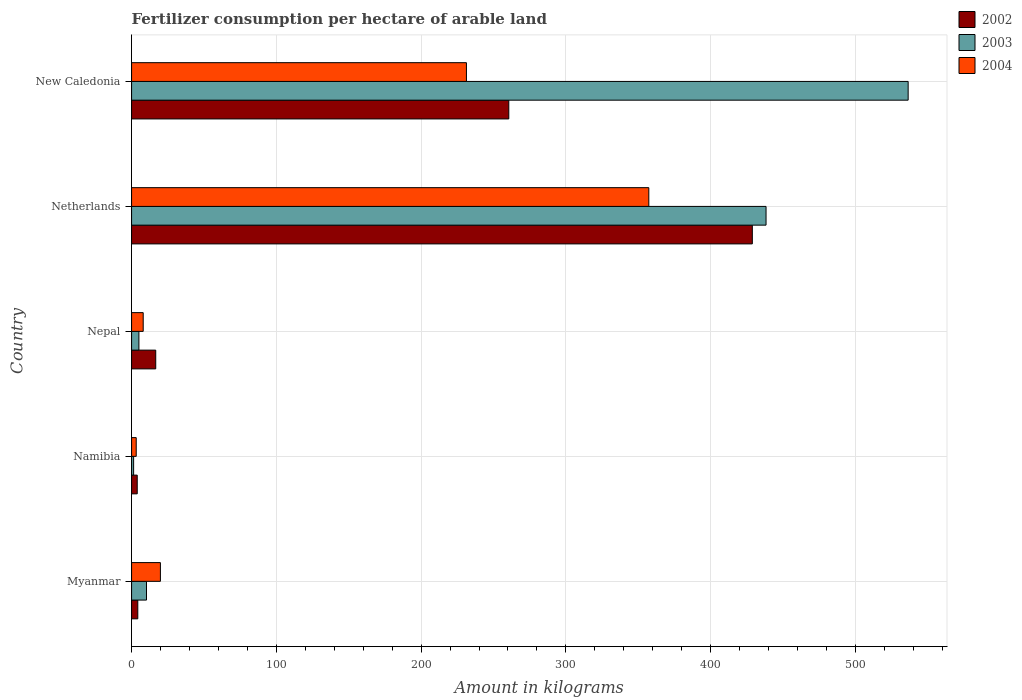How many different coloured bars are there?
Make the answer very short. 3. How many groups of bars are there?
Offer a very short reply. 5. What is the amount of fertilizer consumption in 2003 in Nepal?
Keep it short and to the point. 5.06. Across all countries, what is the maximum amount of fertilizer consumption in 2002?
Your answer should be very brief. 428.82. Across all countries, what is the minimum amount of fertilizer consumption in 2002?
Your answer should be compact. 3.9. In which country was the amount of fertilizer consumption in 2002 maximum?
Keep it short and to the point. Netherlands. In which country was the amount of fertilizer consumption in 2002 minimum?
Offer a very short reply. Namibia. What is the total amount of fertilizer consumption in 2002 in the graph?
Keep it short and to the point. 714.29. What is the difference between the amount of fertilizer consumption in 2003 in Myanmar and that in Netherlands?
Provide a succinct answer. -427.98. What is the difference between the amount of fertilizer consumption in 2004 in Nepal and the amount of fertilizer consumption in 2002 in New Caledonia?
Ensure brevity in your answer.  -252.56. What is the average amount of fertilizer consumption in 2003 per country?
Keep it short and to the point. 198.31. What is the difference between the amount of fertilizer consumption in 2003 and amount of fertilizer consumption in 2004 in New Caledonia?
Ensure brevity in your answer.  305.15. In how many countries, is the amount of fertilizer consumption in 2002 greater than 480 kg?
Offer a terse response. 0. What is the ratio of the amount of fertilizer consumption in 2004 in Myanmar to that in Nepal?
Your response must be concise. 2.48. Is the amount of fertilizer consumption in 2002 in Myanmar less than that in Nepal?
Offer a very short reply. Yes. What is the difference between the highest and the second highest amount of fertilizer consumption in 2003?
Offer a terse response. 98.18. What is the difference between the highest and the lowest amount of fertilizer consumption in 2004?
Provide a succinct answer. 354.11. In how many countries, is the amount of fertilizer consumption in 2002 greater than the average amount of fertilizer consumption in 2002 taken over all countries?
Make the answer very short. 2. Is the sum of the amount of fertilizer consumption in 2002 in Netherlands and New Caledonia greater than the maximum amount of fertilizer consumption in 2003 across all countries?
Give a very brief answer. Yes. What does the 2nd bar from the top in Netherlands represents?
Provide a short and direct response. 2003. What does the 3rd bar from the bottom in Nepal represents?
Your response must be concise. 2004. Is it the case that in every country, the sum of the amount of fertilizer consumption in 2002 and amount of fertilizer consumption in 2003 is greater than the amount of fertilizer consumption in 2004?
Keep it short and to the point. No. What is the difference between two consecutive major ticks on the X-axis?
Offer a terse response. 100. Are the values on the major ticks of X-axis written in scientific E-notation?
Provide a short and direct response. No. Does the graph contain any zero values?
Offer a very short reply. No. Where does the legend appear in the graph?
Provide a short and direct response. Top right. How are the legend labels stacked?
Make the answer very short. Vertical. What is the title of the graph?
Offer a terse response. Fertilizer consumption per hectare of arable land. What is the label or title of the X-axis?
Offer a very short reply. Amount in kilograms. What is the label or title of the Y-axis?
Keep it short and to the point. Country. What is the Amount in kilograms in 2002 in Myanmar?
Offer a terse response. 4.29. What is the Amount in kilograms in 2003 in Myanmar?
Ensure brevity in your answer.  10.31. What is the Amount in kilograms of 2004 in Myanmar?
Your answer should be compact. 19.91. What is the Amount in kilograms of 2002 in Namibia?
Make the answer very short. 3.9. What is the Amount in kilograms of 2003 in Namibia?
Keep it short and to the point. 1.41. What is the Amount in kilograms in 2004 in Namibia?
Provide a short and direct response. 3.2. What is the Amount in kilograms of 2002 in Nepal?
Offer a very short reply. 16.68. What is the Amount in kilograms of 2003 in Nepal?
Make the answer very short. 5.06. What is the Amount in kilograms of 2004 in Nepal?
Keep it short and to the point. 8.03. What is the Amount in kilograms of 2002 in Netherlands?
Make the answer very short. 428.82. What is the Amount in kilograms of 2003 in Netherlands?
Make the answer very short. 438.29. What is the Amount in kilograms in 2004 in Netherlands?
Offer a very short reply. 357.31. What is the Amount in kilograms in 2002 in New Caledonia?
Your response must be concise. 260.59. What is the Amount in kilograms of 2003 in New Caledonia?
Keep it short and to the point. 536.47. What is the Amount in kilograms of 2004 in New Caledonia?
Your answer should be very brief. 231.32. Across all countries, what is the maximum Amount in kilograms of 2002?
Give a very brief answer. 428.82. Across all countries, what is the maximum Amount in kilograms in 2003?
Your answer should be very brief. 536.47. Across all countries, what is the maximum Amount in kilograms of 2004?
Give a very brief answer. 357.31. Across all countries, what is the minimum Amount in kilograms of 2002?
Give a very brief answer. 3.9. Across all countries, what is the minimum Amount in kilograms of 2003?
Make the answer very short. 1.41. Across all countries, what is the minimum Amount in kilograms of 2004?
Ensure brevity in your answer.  3.2. What is the total Amount in kilograms in 2002 in the graph?
Give a very brief answer. 714.29. What is the total Amount in kilograms of 2003 in the graph?
Give a very brief answer. 991.54. What is the total Amount in kilograms in 2004 in the graph?
Your response must be concise. 619.78. What is the difference between the Amount in kilograms in 2002 in Myanmar and that in Namibia?
Keep it short and to the point. 0.39. What is the difference between the Amount in kilograms of 2003 in Myanmar and that in Namibia?
Offer a very short reply. 8.9. What is the difference between the Amount in kilograms in 2004 in Myanmar and that in Namibia?
Keep it short and to the point. 16.71. What is the difference between the Amount in kilograms in 2002 in Myanmar and that in Nepal?
Your answer should be very brief. -12.39. What is the difference between the Amount in kilograms of 2003 in Myanmar and that in Nepal?
Offer a very short reply. 5.25. What is the difference between the Amount in kilograms of 2004 in Myanmar and that in Nepal?
Your response must be concise. 11.89. What is the difference between the Amount in kilograms of 2002 in Myanmar and that in Netherlands?
Provide a succinct answer. -424.53. What is the difference between the Amount in kilograms in 2003 in Myanmar and that in Netherlands?
Ensure brevity in your answer.  -427.98. What is the difference between the Amount in kilograms of 2004 in Myanmar and that in Netherlands?
Give a very brief answer. -337.4. What is the difference between the Amount in kilograms of 2002 in Myanmar and that in New Caledonia?
Ensure brevity in your answer.  -256.3. What is the difference between the Amount in kilograms in 2003 in Myanmar and that in New Caledonia?
Your answer should be very brief. -526.16. What is the difference between the Amount in kilograms in 2004 in Myanmar and that in New Caledonia?
Your answer should be compact. -211.41. What is the difference between the Amount in kilograms of 2002 in Namibia and that in Nepal?
Offer a terse response. -12.78. What is the difference between the Amount in kilograms in 2003 in Namibia and that in Nepal?
Offer a terse response. -3.65. What is the difference between the Amount in kilograms in 2004 in Namibia and that in Nepal?
Provide a succinct answer. -4.82. What is the difference between the Amount in kilograms of 2002 in Namibia and that in Netherlands?
Make the answer very short. -424.92. What is the difference between the Amount in kilograms of 2003 in Namibia and that in Netherlands?
Make the answer very short. -436.88. What is the difference between the Amount in kilograms of 2004 in Namibia and that in Netherlands?
Your answer should be very brief. -354.11. What is the difference between the Amount in kilograms of 2002 in Namibia and that in New Caledonia?
Offer a terse response. -256.69. What is the difference between the Amount in kilograms of 2003 in Namibia and that in New Caledonia?
Give a very brief answer. -535.06. What is the difference between the Amount in kilograms of 2004 in Namibia and that in New Caledonia?
Give a very brief answer. -228.12. What is the difference between the Amount in kilograms in 2002 in Nepal and that in Netherlands?
Your answer should be very brief. -412.14. What is the difference between the Amount in kilograms in 2003 in Nepal and that in Netherlands?
Give a very brief answer. -433.23. What is the difference between the Amount in kilograms of 2004 in Nepal and that in Netherlands?
Keep it short and to the point. -349.29. What is the difference between the Amount in kilograms in 2002 in Nepal and that in New Caledonia?
Your answer should be compact. -243.91. What is the difference between the Amount in kilograms of 2003 in Nepal and that in New Caledonia?
Give a very brief answer. -531.41. What is the difference between the Amount in kilograms in 2004 in Nepal and that in New Caledonia?
Make the answer very short. -223.3. What is the difference between the Amount in kilograms in 2002 in Netherlands and that in New Caledonia?
Provide a succinct answer. 168.23. What is the difference between the Amount in kilograms in 2003 in Netherlands and that in New Caledonia?
Your answer should be very brief. -98.18. What is the difference between the Amount in kilograms of 2004 in Netherlands and that in New Caledonia?
Provide a succinct answer. 125.99. What is the difference between the Amount in kilograms in 2002 in Myanmar and the Amount in kilograms in 2003 in Namibia?
Your response must be concise. 2.88. What is the difference between the Amount in kilograms of 2002 in Myanmar and the Amount in kilograms of 2004 in Namibia?
Keep it short and to the point. 1.09. What is the difference between the Amount in kilograms in 2003 in Myanmar and the Amount in kilograms in 2004 in Namibia?
Provide a short and direct response. 7.1. What is the difference between the Amount in kilograms of 2002 in Myanmar and the Amount in kilograms of 2003 in Nepal?
Provide a succinct answer. -0.77. What is the difference between the Amount in kilograms in 2002 in Myanmar and the Amount in kilograms in 2004 in Nepal?
Your response must be concise. -3.74. What is the difference between the Amount in kilograms of 2003 in Myanmar and the Amount in kilograms of 2004 in Nepal?
Your response must be concise. 2.28. What is the difference between the Amount in kilograms in 2002 in Myanmar and the Amount in kilograms in 2003 in Netherlands?
Make the answer very short. -434. What is the difference between the Amount in kilograms in 2002 in Myanmar and the Amount in kilograms in 2004 in Netherlands?
Give a very brief answer. -353.02. What is the difference between the Amount in kilograms of 2003 in Myanmar and the Amount in kilograms of 2004 in Netherlands?
Make the answer very short. -347. What is the difference between the Amount in kilograms in 2002 in Myanmar and the Amount in kilograms in 2003 in New Caledonia?
Make the answer very short. -532.18. What is the difference between the Amount in kilograms in 2002 in Myanmar and the Amount in kilograms in 2004 in New Caledonia?
Make the answer very short. -227.03. What is the difference between the Amount in kilograms of 2003 in Myanmar and the Amount in kilograms of 2004 in New Caledonia?
Give a very brief answer. -221.01. What is the difference between the Amount in kilograms of 2002 in Namibia and the Amount in kilograms of 2003 in Nepal?
Offer a very short reply. -1.16. What is the difference between the Amount in kilograms in 2002 in Namibia and the Amount in kilograms in 2004 in Nepal?
Ensure brevity in your answer.  -4.12. What is the difference between the Amount in kilograms in 2003 in Namibia and the Amount in kilograms in 2004 in Nepal?
Keep it short and to the point. -6.61. What is the difference between the Amount in kilograms of 2002 in Namibia and the Amount in kilograms of 2003 in Netherlands?
Offer a terse response. -434.39. What is the difference between the Amount in kilograms in 2002 in Namibia and the Amount in kilograms in 2004 in Netherlands?
Provide a short and direct response. -353.41. What is the difference between the Amount in kilograms of 2003 in Namibia and the Amount in kilograms of 2004 in Netherlands?
Keep it short and to the point. -355.9. What is the difference between the Amount in kilograms in 2002 in Namibia and the Amount in kilograms in 2003 in New Caledonia?
Provide a short and direct response. -532.57. What is the difference between the Amount in kilograms in 2002 in Namibia and the Amount in kilograms in 2004 in New Caledonia?
Your response must be concise. -227.42. What is the difference between the Amount in kilograms of 2003 in Namibia and the Amount in kilograms of 2004 in New Caledonia?
Offer a very short reply. -229.91. What is the difference between the Amount in kilograms of 2002 in Nepal and the Amount in kilograms of 2003 in Netherlands?
Provide a short and direct response. -421.61. What is the difference between the Amount in kilograms of 2002 in Nepal and the Amount in kilograms of 2004 in Netherlands?
Give a very brief answer. -340.63. What is the difference between the Amount in kilograms of 2003 in Nepal and the Amount in kilograms of 2004 in Netherlands?
Your response must be concise. -352.25. What is the difference between the Amount in kilograms of 2002 in Nepal and the Amount in kilograms of 2003 in New Caledonia?
Your answer should be compact. -519.79. What is the difference between the Amount in kilograms of 2002 in Nepal and the Amount in kilograms of 2004 in New Caledonia?
Provide a succinct answer. -214.64. What is the difference between the Amount in kilograms of 2003 in Nepal and the Amount in kilograms of 2004 in New Caledonia?
Provide a short and direct response. -226.26. What is the difference between the Amount in kilograms in 2002 in Netherlands and the Amount in kilograms in 2003 in New Caledonia?
Provide a short and direct response. -107.65. What is the difference between the Amount in kilograms in 2002 in Netherlands and the Amount in kilograms in 2004 in New Caledonia?
Your answer should be very brief. 197.5. What is the difference between the Amount in kilograms in 2003 in Netherlands and the Amount in kilograms in 2004 in New Caledonia?
Offer a terse response. 206.97. What is the average Amount in kilograms in 2002 per country?
Your answer should be compact. 142.86. What is the average Amount in kilograms of 2003 per country?
Keep it short and to the point. 198.31. What is the average Amount in kilograms of 2004 per country?
Provide a short and direct response. 123.96. What is the difference between the Amount in kilograms in 2002 and Amount in kilograms in 2003 in Myanmar?
Your answer should be compact. -6.02. What is the difference between the Amount in kilograms in 2002 and Amount in kilograms in 2004 in Myanmar?
Offer a terse response. -15.62. What is the difference between the Amount in kilograms in 2003 and Amount in kilograms in 2004 in Myanmar?
Offer a terse response. -9.6. What is the difference between the Amount in kilograms in 2002 and Amount in kilograms in 2003 in Namibia?
Your answer should be very brief. 2.49. What is the difference between the Amount in kilograms of 2002 and Amount in kilograms of 2004 in Namibia?
Make the answer very short. 0.7. What is the difference between the Amount in kilograms in 2003 and Amount in kilograms in 2004 in Namibia?
Your answer should be very brief. -1.79. What is the difference between the Amount in kilograms in 2002 and Amount in kilograms in 2003 in Nepal?
Ensure brevity in your answer.  11.62. What is the difference between the Amount in kilograms in 2002 and Amount in kilograms in 2004 in Nepal?
Offer a terse response. 8.66. What is the difference between the Amount in kilograms in 2003 and Amount in kilograms in 2004 in Nepal?
Keep it short and to the point. -2.97. What is the difference between the Amount in kilograms of 2002 and Amount in kilograms of 2003 in Netherlands?
Give a very brief answer. -9.47. What is the difference between the Amount in kilograms of 2002 and Amount in kilograms of 2004 in Netherlands?
Your response must be concise. 71.51. What is the difference between the Amount in kilograms of 2003 and Amount in kilograms of 2004 in Netherlands?
Offer a very short reply. 80.98. What is the difference between the Amount in kilograms of 2002 and Amount in kilograms of 2003 in New Caledonia?
Keep it short and to the point. -275.88. What is the difference between the Amount in kilograms of 2002 and Amount in kilograms of 2004 in New Caledonia?
Give a very brief answer. 29.26. What is the difference between the Amount in kilograms in 2003 and Amount in kilograms in 2004 in New Caledonia?
Make the answer very short. 305.15. What is the ratio of the Amount in kilograms of 2002 in Myanmar to that in Namibia?
Keep it short and to the point. 1.1. What is the ratio of the Amount in kilograms of 2003 in Myanmar to that in Namibia?
Your answer should be compact. 7.31. What is the ratio of the Amount in kilograms in 2004 in Myanmar to that in Namibia?
Ensure brevity in your answer.  6.21. What is the ratio of the Amount in kilograms of 2002 in Myanmar to that in Nepal?
Provide a short and direct response. 0.26. What is the ratio of the Amount in kilograms in 2003 in Myanmar to that in Nepal?
Make the answer very short. 2.04. What is the ratio of the Amount in kilograms of 2004 in Myanmar to that in Nepal?
Make the answer very short. 2.48. What is the ratio of the Amount in kilograms in 2002 in Myanmar to that in Netherlands?
Offer a very short reply. 0.01. What is the ratio of the Amount in kilograms in 2003 in Myanmar to that in Netherlands?
Provide a short and direct response. 0.02. What is the ratio of the Amount in kilograms in 2004 in Myanmar to that in Netherlands?
Provide a short and direct response. 0.06. What is the ratio of the Amount in kilograms in 2002 in Myanmar to that in New Caledonia?
Provide a short and direct response. 0.02. What is the ratio of the Amount in kilograms in 2003 in Myanmar to that in New Caledonia?
Your answer should be very brief. 0.02. What is the ratio of the Amount in kilograms in 2004 in Myanmar to that in New Caledonia?
Provide a succinct answer. 0.09. What is the ratio of the Amount in kilograms of 2002 in Namibia to that in Nepal?
Offer a very short reply. 0.23. What is the ratio of the Amount in kilograms in 2003 in Namibia to that in Nepal?
Your response must be concise. 0.28. What is the ratio of the Amount in kilograms in 2004 in Namibia to that in Nepal?
Your answer should be compact. 0.4. What is the ratio of the Amount in kilograms of 2002 in Namibia to that in Netherlands?
Provide a succinct answer. 0.01. What is the ratio of the Amount in kilograms of 2003 in Namibia to that in Netherlands?
Your response must be concise. 0. What is the ratio of the Amount in kilograms in 2004 in Namibia to that in Netherlands?
Offer a very short reply. 0.01. What is the ratio of the Amount in kilograms of 2002 in Namibia to that in New Caledonia?
Give a very brief answer. 0.01. What is the ratio of the Amount in kilograms of 2003 in Namibia to that in New Caledonia?
Ensure brevity in your answer.  0. What is the ratio of the Amount in kilograms in 2004 in Namibia to that in New Caledonia?
Keep it short and to the point. 0.01. What is the ratio of the Amount in kilograms in 2002 in Nepal to that in Netherlands?
Ensure brevity in your answer.  0.04. What is the ratio of the Amount in kilograms in 2003 in Nepal to that in Netherlands?
Provide a succinct answer. 0.01. What is the ratio of the Amount in kilograms of 2004 in Nepal to that in Netherlands?
Keep it short and to the point. 0.02. What is the ratio of the Amount in kilograms of 2002 in Nepal to that in New Caledonia?
Provide a short and direct response. 0.06. What is the ratio of the Amount in kilograms of 2003 in Nepal to that in New Caledonia?
Your answer should be very brief. 0.01. What is the ratio of the Amount in kilograms in 2004 in Nepal to that in New Caledonia?
Your answer should be very brief. 0.03. What is the ratio of the Amount in kilograms in 2002 in Netherlands to that in New Caledonia?
Ensure brevity in your answer.  1.65. What is the ratio of the Amount in kilograms in 2003 in Netherlands to that in New Caledonia?
Offer a terse response. 0.82. What is the ratio of the Amount in kilograms in 2004 in Netherlands to that in New Caledonia?
Give a very brief answer. 1.54. What is the difference between the highest and the second highest Amount in kilograms of 2002?
Keep it short and to the point. 168.23. What is the difference between the highest and the second highest Amount in kilograms of 2003?
Keep it short and to the point. 98.18. What is the difference between the highest and the second highest Amount in kilograms of 2004?
Offer a terse response. 125.99. What is the difference between the highest and the lowest Amount in kilograms of 2002?
Keep it short and to the point. 424.92. What is the difference between the highest and the lowest Amount in kilograms of 2003?
Ensure brevity in your answer.  535.06. What is the difference between the highest and the lowest Amount in kilograms of 2004?
Offer a terse response. 354.11. 